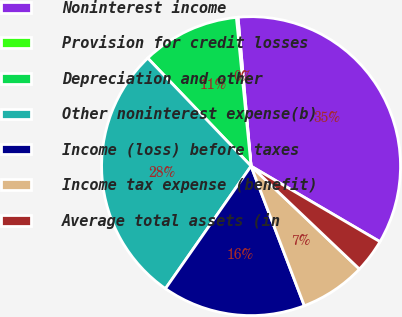<chart> <loc_0><loc_0><loc_500><loc_500><pie_chart><fcel>Noninterest income<fcel>Provision for credit losses<fcel>Depreciation and other<fcel>Other noninterest expense(b)<fcel>Income (loss) before taxes<fcel>Income tax expense (benefit)<fcel>Average total assets (in<nl><fcel>34.83%<fcel>0.18%<fcel>10.58%<fcel>28.15%<fcel>15.51%<fcel>7.11%<fcel>3.65%<nl></chart> 